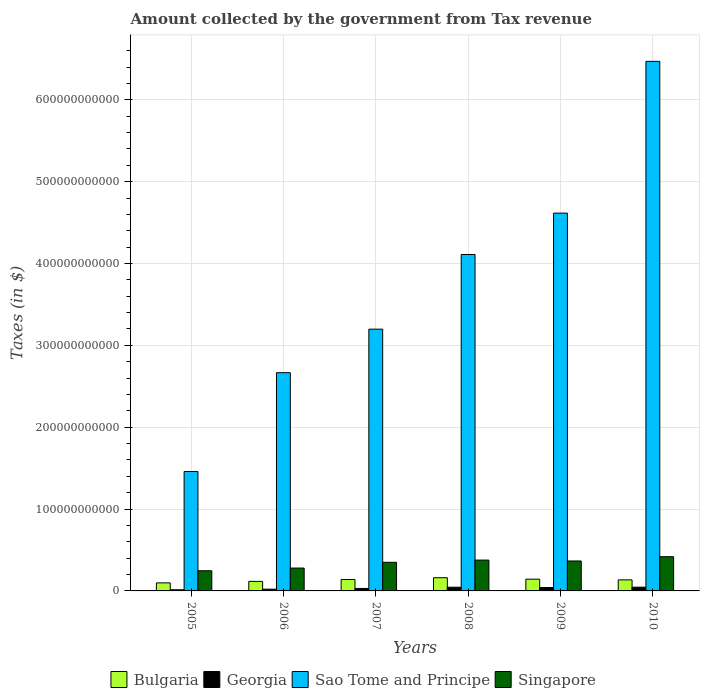How many groups of bars are there?
Your response must be concise. 6. Are the number of bars on each tick of the X-axis equal?
Ensure brevity in your answer.  Yes. How many bars are there on the 6th tick from the right?
Provide a short and direct response. 4. What is the label of the 6th group of bars from the left?
Give a very brief answer. 2010. What is the amount collected by the government from tax revenue in Sao Tome and Principe in 2009?
Your answer should be very brief. 4.62e+11. Across all years, what is the maximum amount collected by the government from tax revenue in Georgia?
Give a very brief answer. 4.59e+09. Across all years, what is the minimum amount collected by the government from tax revenue in Sao Tome and Principe?
Your response must be concise. 1.46e+11. In which year was the amount collected by the government from tax revenue in Bulgaria maximum?
Offer a terse response. 2008. In which year was the amount collected by the government from tax revenue in Singapore minimum?
Provide a short and direct response. 2005. What is the total amount collected by the government from tax revenue in Georgia in the graph?
Offer a very short reply. 1.98e+1. What is the difference between the amount collected by the government from tax revenue in Georgia in 2005 and that in 2009?
Make the answer very short. -2.75e+09. What is the difference between the amount collected by the government from tax revenue in Georgia in 2007 and the amount collected by the government from tax revenue in Singapore in 2010?
Make the answer very short. -3.88e+1. What is the average amount collected by the government from tax revenue in Singapore per year?
Your answer should be very brief. 3.39e+1. In the year 2008, what is the difference between the amount collected by the government from tax revenue in Georgia and amount collected by the government from tax revenue in Bulgaria?
Your response must be concise. -1.16e+1. In how many years, is the amount collected by the government from tax revenue in Sao Tome and Principe greater than 40000000000 $?
Give a very brief answer. 6. What is the ratio of the amount collected by the government from tax revenue in Sao Tome and Principe in 2005 to that in 2007?
Your answer should be very brief. 0.46. Is the amount collected by the government from tax revenue in Sao Tome and Principe in 2007 less than that in 2008?
Offer a terse response. Yes. Is the difference between the amount collected by the government from tax revenue in Georgia in 2008 and 2009 greater than the difference between the amount collected by the government from tax revenue in Bulgaria in 2008 and 2009?
Your answer should be very brief. No. What is the difference between the highest and the second highest amount collected by the government from tax revenue in Sao Tome and Principe?
Your answer should be compact. 1.85e+11. What is the difference between the highest and the lowest amount collected by the government from tax revenue in Bulgaria?
Provide a short and direct response. 6.30e+09. What does the 3rd bar from the left in 2006 represents?
Provide a succinct answer. Sao Tome and Principe. What does the 2nd bar from the right in 2005 represents?
Offer a terse response. Sao Tome and Principe. How many bars are there?
Offer a very short reply. 24. Are all the bars in the graph horizontal?
Offer a terse response. No. How many years are there in the graph?
Provide a short and direct response. 6. What is the difference between two consecutive major ticks on the Y-axis?
Make the answer very short. 1.00e+11. Are the values on the major ticks of Y-axis written in scientific E-notation?
Ensure brevity in your answer.  No. Does the graph contain grids?
Give a very brief answer. Yes. How many legend labels are there?
Provide a short and direct response. 4. How are the legend labels stacked?
Ensure brevity in your answer.  Horizontal. What is the title of the graph?
Offer a terse response. Amount collected by the government from Tax revenue. Does "Hungary" appear as one of the legend labels in the graph?
Give a very brief answer. No. What is the label or title of the X-axis?
Offer a very short reply. Years. What is the label or title of the Y-axis?
Your answer should be compact. Taxes (in $). What is the Taxes (in $) of Bulgaria in 2005?
Keep it short and to the point. 9.83e+09. What is the Taxes (in $) of Georgia in 2005?
Make the answer very short. 1.41e+09. What is the Taxes (in $) of Sao Tome and Principe in 2005?
Make the answer very short. 1.46e+11. What is the Taxes (in $) in Singapore in 2005?
Ensure brevity in your answer.  2.46e+1. What is the Taxes (in $) in Bulgaria in 2006?
Make the answer very short. 1.17e+1. What is the Taxes (in $) in Georgia in 2006?
Keep it short and to the point. 2.13e+09. What is the Taxes (in $) in Sao Tome and Principe in 2006?
Your answer should be compact. 2.67e+11. What is the Taxes (in $) of Singapore in 2006?
Offer a very short reply. 2.79e+1. What is the Taxes (in $) in Bulgaria in 2007?
Your response must be concise. 1.39e+1. What is the Taxes (in $) in Georgia in 2007?
Make the answer very short. 3.01e+09. What is the Taxes (in $) in Sao Tome and Principe in 2007?
Ensure brevity in your answer.  3.20e+11. What is the Taxes (in $) of Singapore in 2007?
Offer a very short reply. 3.50e+1. What is the Taxes (in $) of Bulgaria in 2008?
Make the answer very short. 1.61e+1. What is the Taxes (in $) of Georgia in 2008?
Give a very brief answer. 4.54e+09. What is the Taxes (in $) of Sao Tome and Principe in 2008?
Your answer should be compact. 4.11e+11. What is the Taxes (in $) in Singapore in 2008?
Provide a short and direct response. 3.77e+1. What is the Taxes (in $) of Bulgaria in 2009?
Provide a succinct answer. 1.44e+1. What is the Taxes (in $) in Georgia in 2009?
Make the answer very short. 4.16e+09. What is the Taxes (in $) of Sao Tome and Principe in 2009?
Your answer should be compact. 4.62e+11. What is the Taxes (in $) in Singapore in 2009?
Make the answer very short. 3.66e+1. What is the Taxes (in $) in Bulgaria in 2010?
Ensure brevity in your answer.  1.35e+1. What is the Taxes (in $) of Georgia in 2010?
Offer a terse response. 4.59e+09. What is the Taxes (in $) in Sao Tome and Principe in 2010?
Keep it short and to the point. 6.47e+11. What is the Taxes (in $) in Singapore in 2010?
Offer a terse response. 4.18e+1. Across all years, what is the maximum Taxes (in $) in Bulgaria?
Give a very brief answer. 1.61e+1. Across all years, what is the maximum Taxes (in $) of Georgia?
Provide a short and direct response. 4.59e+09. Across all years, what is the maximum Taxes (in $) in Sao Tome and Principe?
Your answer should be compact. 6.47e+11. Across all years, what is the maximum Taxes (in $) in Singapore?
Your answer should be very brief. 4.18e+1. Across all years, what is the minimum Taxes (in $) in Bulgaria?
Your answer should be very brief. 9.83e+09. Across all years, what is the minimum Taxes (in $) in Georgia?
Offer a very short reply. 1.41e+09. Across all years, what is the minimum Taxes (in $) of Sao Tome and Principe?
Offer a very short reply. 1.46e+11. Across all years, what is the minimum Taxes (in $) of Singapore?
Keep it short and to the point. 2.46e+1. What is the total Taxes (in $) in Bulgaria in the graph?
Your answer should be very brief. 7.94e+1. What is the total Taxes (in $) in Georgia in the graph?
Keep it short and to the point. 1.98e+1. What is the total Taxes (in $) of Sao Tome and Principe in the graph?
Your answer should be very brief. 2.25e+12. What is the total Taxes (in $) in Singapore in the graph?
Your response must be concise. 2.04e+11. What is the difference between the Taxes (in $) in Bulgaria in 2005 and that in 2006?
Give a very brief answer. -1.82e+09. What is the difference between the Taxes (in $) of Georgia in 2005 and that in 2006?
Provide a succinct answer. -7.23e+08. What is the difference between the Taxes (in $) in Sao Tome and Principe in 2005 and that in 2006?
Your response must be concise. -1.21e+11. What is the difference between the Taxes (in $) in Singapore in 2005 and that in 2006?
Your answer should be very brief. -3.31e+09. What is the difference between the Taxes (in $) of Bulgaria in 2005 and that in 2007?
Offer a very short reply. -4.09e+09. What is the difference between the Taxes (in $) of Georgia in 2005 and that in 2007?
Provide a short and direct response. -1.60e+09. What is the difference between the Taxes (in $) of Sao Tome and Principe in 2005 and that in 2007?
Your response must be concise. -1.74e+11. What is the difference between the Taxes (in $) of Singapore in 2005 and that in 2007?
Provide a short and direct response. -1.03e+1. What is the difference between the Taxes (in $) in Bulgaria in 2005 and that in 2008?
Give a very brief answer. -6.30e+09. What is the difference between the Taxes (in $) of Georgia in 2005 and that in 2008?
Offer a very short reply. -3.13e+09. What is the difference between the Taxes (in $) in Sao Tome and Principe in 2005 and that in 2008?
Offer a terse response. -2.65e+11. What is the difference between the Taxes (in $) in Singapore in 2005 and that in 2008?
Offer a terse response. -1.31e+1. What is the difference between the Taxes (in $) of Bulgaria in 2005 and that in 2009?
Your response must be concise. -4.53e+09. What is the difference between the Taxes (in $) of Georgia in 2005 and that in 2009?
Provide a short and direct response. -2.75e+09. What is the difference between the Taxes (in $) in Sao Tome and Principe in 2005 and that in 2009?
Your response must be concise. -3.16e+11. What is the difference between the Taxes (in $) of Singapore in 2005 and that in 2009?
Offer a terse response. -1.20e+1. What is the difference between the Taxes (in $) of Bulgaria in 2005 and that in 2010?
Give a very brief answer. -3.67e+09. What is the difference between the Taxes (in $) of Georgia in 2005 and that in 2010?
Provide a short and direct response. -3.19e+09. What is the difference between the Taxes (in $) of Sao Tome and Principe in 2005 and that in 2010?
Offer a very short reply. -5.01e+11. What is the difference between the Taxes (in $) in Singapore in 2005 and that in 2010?
Provide a short and direct response. -1.72e+1. What is the difference between the Taxes (in $) in Bulgaria in 2006 and that in 2007?
Keep it short and to the point. -2.27e+09. What is the difference between the Taxes (in $) of Georgia in 2006 and that in 2007?
Ensure brevity in your answer.  -8.80e+08. What is the difference between the Taxes (in $) of Sao Tome and Principe in 2006 and that in 2007?
Offer a very short reply. -5.32e+1. What is the difference between the Taxes (in $) of Singapore in 2006 and that in 2007?
Offer a terse response. -7.02e+09. What is the difference between the Taxes (in $) in Bulgaria in 2006 and that in 2008?
Provide a short and direct response. -4.47e+09. What is the difference between the Taxes (in $) of Georgia in 2006 and that in 2008?
Make the answer very short. -2.41e+09. What is the difference between the Taxes (in $) of Sao Tome and Principe in 2006 and that in 2008?
Your answer should be very brief. -1.44e+11. What is the difference between the Taxes (in $) of Singapore in 2006 and that in 2008?
Provide a succinct answer. -9.74e+09. What is the difference between the Taxes (in $) of Bulgaria in 2006 and that in 2009?
Keep it short and to the point. -2.71e+09. What is the difference between the Taxes (in $) of Georgia in 2006 and that in 2009?
Give a very brief answer. -2.03e+09. What is the difference between the Taxes (in $) in Sao Tome and Principe in 2006 and that in 2009?
Keep it short and to the point. -1.95e+11. What is the difference between the Taxes (in $) in Singapore in 2006 and that in 2009?
Provide a succinct answer. -8.64e+09. What is the difference between the Taxes (in $) in Bulgaria in 2006 and that in 2010?
Your response must be concise. -1.85e+09. What is the difference between the Taxes (in $) of Georgia in 2006 and that in 2010?
Your answer should be compact. -2.46e+09. What is the difference between the Taxes (in $) in Sao Tome and Principe in 2006 and that in 2010?
Your response must be concise. -3.80e+11. What is the difference between the Taxes (in $) in Singapore in 2006 and that in 2010?
Offer a very short reply. -1.39e+1. What is the difference between the Taxes (in $) in Bulgaria in 2007 and that in 2008?
Ensure brevity in your answer.  -2.20e+09. What is the difference between the Taxes (in $) of Georgia in 2007 and that in 2008?
Your response must be concise. -1.53e+09. What is the difference between the Taxes (in $) in Sao Tome and Principe in 2007 and that in 2008?
Keep it short and to the point. -9.12e+1. What is the difference between the Taxes (in $) of Singapore in 2007 and that in 2008?
Keep it short and to the point. -2.72e+09. What is the difference between the Taxes (in $) of Bulgaria in 2007 and that in 2009?
Offer a very short reply. -4.37e+08. What is the difference between the Taxes (in $) of Georgia in 2007 and that in 2009?
Your answer should be compact. -1.15e+09. What is the difference between the Taxes (in $) in Sao Tome and Principe in 2007 and that in 2009?
Provide a succinct answer. -1.42e+11. What is the difference between the Taxes (in $) of Singapore in 2007 and that in 2009?
Your response must be concise. -1.62e+09. What is the difference between the Taxes (in $) in Bulgaria in 2007 and that in 2010?
Your answer should be compact. 4.21e+08. What is the difference between the Taxes (in $) in Georgia in 2007 and that in 2010?
Provide a short and direct response. -1.58e+09. What is the difference between the Taxes (in $) in Sao Tome and Principe in 2007 and that in 2010?
Your answer should be compact. -3.27e+11. What is the difference between the Taxes (in $) in Singapore in 2007 and that in 2010?
Give a very brief answer. -6.85e+09. What is the difference between the Taxes (in $) in Bulgaria in 2008 and that in 2009?
Your response must be concise. 1.77e+09. What is the difference between the Taxes (in $) in Georgia in 2008 and that in 2009?
Your answer should be compact. 3.80e+08. What is the difference between the Taxes (in $) of Sao Tome and Principe in 2008 and that in 2009?
Your answer should be very brief. -5.06e+1. What is the difference between the Taxes (in $) of Singapore in 2008 and that in 2009?
Your answer should be very brief. 1.10e+09. What is the difference between the Taxes (in $) of Bulgaria in 2008 and that in 2010?
Make the answer very short. 2.62e+09. What is the difference between the Taxes (in $) in Georgia in 2008 and that in 2010?
Provide a short and direct response. -5.08e+07. What is the difference between the Taxes (in $) in Sao Tome and Principe in 2008 and that in 2010?
Make the answer very short. -2.36e+11. What is the difference between the Taxes (in $) in Singapore in 2008 and that in 2010?
Keep it short and to the point. -4.13e+09. What is the difference between the Taxes (in $) in Bulgaria in 2009 and that in 2010?
Make the answer very short. 8.58e+08. What is the difference between the Taxes (in $) in Georgia in 2009 and that in 2010?
Your answer should be compact. -4.31e+08. What is the difference between the Taxes (in $) of Sao Tome and Principe in 2009 and that in 2010?
Offer a very short reply. -1.85e+11. What is the difference between the Taxes (in $) of Singapore in 2009 and that in 2010?
Provide a succinct answer. -5.22e+09. What is the difference between the Taxes (in $) in Bulgaria in 2005 and the Taxes (in $) in Georgia in 2006?
Your answer should be very brief. 7.70e+09. What is the difference between the Taxes (in $) in Bulgaria in 2005 and the Taxes (in $) in Sao Tome and Principe in 2006?
Offer a terse response. -2.57e+11. What is the difference between the Taxes (in $) of Bulgaria in 2005 and the Taxes (in $) of Singapore in 2006?
Offer a very short reply. -1.81e+1. What is the difference between the Taxes (in $) in Georgia in 2005 and the Taxes (in $) in Sao Tome and Principe in 2006?
Offer a very short reply. -2.65e+11. What is the difference between the Taxes (in $) of Georgia in 2005 and the Taxes (in $) of Singapore in 2006?
Give a very brief answer. -2.65e+1. What is the difference between the Taxes (in $) of Sao Tome and Principe in 2005 and the Taxes (in $) of Singapore in 2006?
Offer a very short reply. 1.18e+11. What is the difference between the Taxes (in $) of Bulgaria in 2005 and the Taxes (in $) of Georgia in 2007?
Offer a terse response. 6.82e+09. What is the difference between the Taxes (in $) of Bulgaria in 2005 and the Taxes (in $) of Sao Tome and Principe in 2007?
Keep it short and to the point. -3.10e+11. What is the difference between the Taxes (in $) in Bulgaria in 2005 and the Taxes (in $) in Singapore in 2007?
Offer a terse response. -2.51e+1. What is the difference between the Taxes (in $) of Georgia in 2005 and the Taxes (in $) of Sao Tome and Principe in 2007?
Offer a terse response. -3.18e+11. What is the difference between the Taxes (in $) of Georgia in 2005 and the Taxes (in $) of Singapore in 2007?
Offer a very short reply. -3.36e+1. What is the difference between the Taxes (in $) of Sao Tome and Principe in 2005 and the Taxes (in $) of Singapore in 2007?
Keep it short and to the point. 1.11e+11. What is the difference between the Taxes (in $) of Bulgaria in 2005 and the Taxes (in $) of Georgia in 2008?
Your response must be concise. 5.29e+09. What is the difference between the Taxes (in $) of Bulgaria in 2005 and the Taxes (in $) of Sao Tome and Principe in 2008?
Make the answer very short. -4.01e+11. What is the difference between the Taxes (in $) of Bulgaria in 2005 and the Taxes (in $) of Singapore in 2008?
Offer a terse response. -2.78e+1. What is the difference between the Taxes (in $) of Georgia in 2005 and the Taxes (in $) of Sao Tome and Principe in 2008?
Keep it short and to the point. -4.10e+11. What is the difference between the Taxes (in $) of Georgia in 2005 and the Taxes (in $) of Singapore in 2008?
Your answer should be very brief. -3.63e+1. What is the difference between the Taxes (in $) in Sao Tome and Principe in 2005 and the Taxes (in $) in Singapore in 2008?
Offer a very short reply. 1.08e+11. What is the difference between the Taxes (in $) of Bulgaria in 2005 and the Taxes (in $) of Georgia in 2009?
Offer a very short reply. 5.67e+09. What is the difference between the Taxes (in $) of Bulgaria in 2005 and the Taxes (in $) of Sao Tome and Principe in 2009?
Make the answer very short. -4.52e+11. What is the difference between the Taxes (in $) in Bulgaria in 2005 and the Taxes (in $) in Singapore in 2009?
Ensure brevity in your answer.  -2.68e+1. What is the difference between the Taxes (in $) in Georgia in 2005 and the Taxes (in $) in Sao Tome and Principe in 2009?
Provide a short and direct response. -4.60e+11. What is the difference between the Taxes (in $) of Georgia in 2005 and the Taxes (in $) of Singapore in 2009?
Ensure brevity in your answer.  -3.52e+1. What is the difference between the Taxes (in $) of Sao Tome and Principe in 2005 and the Taxes (in $) of Singapore in 2009?
Offer a very short reply. 1.09e+11. What is the difference between the Taxes (in $) in Bulgaria in 2005 and the Taxes (in $) in Georgia in 2010?
Make the answer very short. 5.24e+09. What is the difference between the Taxes (in $) in Bulgaria in 2005 and the Taxes (in $) in Sao Tome and Principe in 2010?
Your answer should be compact. -6.37e+11. What is the difference between the Taxes (in $) of Bulgaria in 2005 and the Taxes (in $) of Singapore in 2010?
Ensure brevity in your answer.  -3.20e+1. What is the difference between the Taxes (in $) of Georgia in 2005 and the Taxes (in $) of Sao Tome and Principe in 2010?
Give a very brief answer. -6.46e+11. What is the difference between the Taxes (in $) of Georgia in 2005 and the Taxes (in $) of Singapore in 2010?
Your response must be concise. -4.04e+1. What is the difference between the Taxes (in $) of Sao Tome and Principe in 2005 and the Taxes (in $) of Singapore in 2010?
Your answer should be very brief. 1.04e+11. What is the difference between the Taxes (in $) in Bulgaria in 2006 and the Taxes (in $) in Georgia in 2007?
Offer a terse response. 8.64e+09. What is the difference between the Taxes (in $) in Bulgaria in 2006 and the Taxes (in $) in Sao Tome and Principe in 2007?
Give a very brief answer. -3.08e+11. What is the difference between the Taxes (in $) in Bulgaria in 2006 and the Taxes (in $) in Singapore in 2007?
Ensure brevity in your answer.  -2.33e+1. What is the difference between the Taxes (in $) of Georgia in 2006 and the Taxes (in $) of Sao Tome and Principe in 2007?
Your answer should be compact. -3.18e+11. What is the difference between the Taxes (in $) in Georgia in 2006 and the Taxes (in $) in Singapore in 2007?
Keep it short and to the point. -3.28e+1. What is the difference between the Taxes (in $) of Sao Tome and Principe in 2006 and the Taxes (in $) of Singapore in 2007?
Your answer should be very brief. 2.32e+11. What is the difference between the Taxes (in $) of Bulgaria in 2006 and the Taxes (in $) of Georgia in 2008?
Give a very brief answer. 7.11e+09. What is the difference between the Taxes (in $) of Bulgaria in 2006 and the Taxes (in $) of Sao Tome and Principe in 2008?
Provide a short and direct response. -3.99e+11. What is the difference between the Taxes (in $) of Bulgaria in 2006 and the Taxes (in $) of Singapore in 2008?
Make the answer very short. -2.60e+1. What is the difference between the Taxes (in $) in Georgia in 2006 and the Taxes (in $) in Sao Tome and Principe in 2008?
Your answer should be compact. -4.09e+11. What is the difference between the Taxes (in $) of Georgia in 2006 and the Taxes (in $) of Singapore in 2008?
Give a very brief answer. -3.55e+1. What is the difference between the Taxes (in $) in Sao Tome and Principe in 2006 and the Taxes (in $) in Singapore in 2008?
Provide a succinct answer. 2.29e+11. What is the difference between the Taxes (in $) of Bulgaria in 2006 and the Taxes (in $) of Georgia in 2009?
Ensure brevity in your answer.  7.49e+09. What is the difference between the Taxes (in $) in Bulgaria in 2006 and the Taxes (in $) in Sao Tome and Principe in 2009?
Keep it short and to the point. -4.50e+11. What is the difference between the Taxes (in $) in Bulgaria in 2006 and the Taxes (in $) in Singapore in 2009?
Ensure brevity in your answer.  -2.49e+1. What is the difference between the Taxes (in $) in Georgia in 2006 and the Taxes (in $) in Sao Tome and Principe in 2009?
Make the answer very short. -4.59e+11. What is the difference between the Taxes (in $) of Georgia in 2006 and the Taxes (in $) of Singapore in 2009?
Provide a succinct answer. -3.45e+1. What is the difference between the Taxes (in $) in Sao Tome and Principe in 2006 and the Taxes (in $) in Singapore in 2009?
Give a very brief answer. 2.30e+11. What is the difference between the Taxes (in $) in Bulgaria in 2006 and the Taxes (in $) in Georgia in 2010?
Ensure brevity in your answer.  7.06e+09. What is the difference between the Taxes (in $) in Bulgaria in 2006 and the Taxes (in $) in Sao Tome and Principe in 2010?
Provide a short and direct response. -6.35e+11. What is the difference between the Taxes (in $) of Bulgaria in 2006 and the Taxes (in $) of Singapore in 2010?
Ensure brevity in your answer.  -3.02e+1. What is the difference between the Taxes (in $) in Georgia in 2006 and the Taxes (in $) in Sao Tome and Principe in 2010?
Your answer should be very brief. -6.45e+11. What is the difference between the Taxes (in $) of Georgia in 2006 and the Taxes (in $) of Singapore in 2010?
Provide a succinct answer. -3.97e+1. What is the difference between the Taxes (in $) in Sao Tome and Principe in 2006 and the Taxes (in $) in Singapore in 2010?
Offer a very short reply. 2.25e+11. What is the difference between the Taxes (in $) in Bulgaria in 2007 and the Taxes (in $) in Georgia in 2008?
Provide a succinct answer. 9.38e+09. What is the difference between the Taxes (in $) of Bulgaria in 2007 and the Taxes (in $) of Sao Tome and Principe in 2008?
Make the answer very short. -3.97e+11. What is the difference between the Taxes (in $) in Bulgaria in 2007 and the Taxes (in $) in Singapore in 2008?
Your response must be concise. -2.38e+1. What is the difference between the Taxes (in $) of Georgia in 2007 and the Taxes (in $) of Sao Tome and Principe in 2008?
Give a very brief answer. -4.08e+11. What is the difference between the Taxes (in $) of Georgia in 2007 and the Taxes (in $) of Singapore in 2008?
Provide a succinct answer. -3.47e+1. What is the difference between the Taxes (in $) of Sao Tome and Principe in 2007 and the Taxes (in $) of Singapore in 2008?
Give a very brief answer. 2.82e+11. What is the difference between the Taxes (in $) in Bulgaria in 2007 and the Taxes (in $) in Georgia in 2009?
Provide a short and direct response. 9.76e+09. What is the difference between the Taxes (in $) in Bulgaria in 2007 and the Taxes (in $) in Sao Tome and Principe in 2009?
Ensure brevity in your answer.  -4.48e+11. What is the difference between the Taxes (in $) of Bulgaria in 2007 and the Taxes (in $) of Singapore in 2009?
Make the answer very short. -2.27e+1. What is the difference between the Taxes (in $) of Georgia in 2007 and the Taxes (in $) of Sao Tome and Principe in 2009?
Offer a very short reply. -4.59e+11. What is the difference between the Taxes (in $) in Georgia in 2007 and the Taxes (in $) in Singapore in 2009?
Your response must be concise. -3.36e+1. What is the difference between the Taxes (in $) of Sao Tome and Principe in 2007 and the Taxes (in $) of Singapore in 2009?
Keep it short and to the point. 2.83e+11. What is the difference between the Taxes (in $) in Bulgaria in 2007 and the Taxes (in $) in Georgia in 2010?
Your answer should be very brief. 9.33e+09. What is the difference between the Taxes (in $) in Bulgaria in 2007 and the Taxes (in $) in Sao Tome and Principe in 2010?
Your answer should be compact. -6.33e+11. What is the difference between the Taxes (in $) of Bulgaria in 2007 and the Taxes (in $) of Singapore in 2010?
Your answer should be very brief. -2.79e+1. What is the difference between the Taxes (in $) of Georgia in 2007 and the Taxes (in $) of Sao Tome and Principe in 2010?
Offer a very short reply. -6.44e+11. What is the difference between the Taxes (in $) of Georgia in 2007 and the Taxes (in $) of Singapore in 2010?
Offer a very short reply. -3.88e+1. What is the difference between the Taxes (in $) in Sao Tome and Principe in 2007 and the Taxes (in $) in Singapore in 2010?
Offer a terse response. 2.78e+11. What is the difference between the Taxes (in $) of Bulgaria in 2008 and the Taxes (in $) of Georgia in 2009?
Give a very brief answer. 1.20e+1. What is the difference between the Taxes (in $) of Bulgaria in 2008 and the Taxes (in $) of Sao Tome and Principe in 2009?
Keep it short and to the point. -4.45e+11. What is the difference between the Taxes (in $) of Bulgaria in 2008 and the Taxes (in $) of Singapore in 2009?
Provide a succinct answer. -2.05e+1. What is the difference between the Taxes (in $) in Georgia in 2008 and the Taxes (in $) in Sao Tome and Principe in 2009?
Provide a short and direct response. -4.57e+11. What is the difference between the Taxes (in $) of Georgia in 2008 and the Taxes (in $) of Singapore in 2009?
Provide a short and direct response. -3.20e+1. What is the difference between the Taxes (in $) in Sao Tome and Principe in 2008 and the Taxes (in $) in Singapore in 2009?
Offer a very short reply. 3.74e+11. What is the difference between the Taxes (in $) of Bulgaria in 2008 and the Taxes (in $) of Georgia in 2010?
Offer a terse response. 1.15e+1. What is the difference between the Taxes (in $) of Bulgaria in 2008 and the Taxes (in $) of Sao Tome and Principe in 2010?
Give a very brief answer. -6.31e+11. What is the difference between the Taxes (in $) in Bulgaria in 2008 and the Taxes (in $) in Singapore in 2010?
Your answer should be very brief. -2.57e+1. What is the difference between the Taxes (in $) in Georgia in 2008 and the Taxes (in $) in Sao Tome and Principe in 2010?
Offer a terse response. -6.42e+11. What is the difference between the Taxes (in $) in Georgia in 2008 and the Taxes (in $) in Singapore in 2010?
Keep it short and to the point. -3.73e+1. What is the difference between the Taxes (in $) in Sao Tome and Principe in 2008 and the Taxes (in $) in Singapore in 2010?
Give a very brief answer. 3.69e+11. What is the difference between the Taxes (in $) of Bulgaria in 2009 and the Taxes (in $) of Georgia in 2010?
Keep it short and to the point. 9.77e+09. What is the difference between the Taxes (in $) in Bulgaria in 2009 and the Taxes (in $) in Sao Tome and Principe in 2010?
Provide a succinct answer. -6.33e+11. What is the difference between the Taxes (in $) of Bulgaria in 2009 and the Taxes (in $) of Singapore in 2010?
Provide a succinct answer. -2.74e+1. What is the difference between the Taxes (in $) of Georgia in 2009 and the Taxes (in $) of Sao Tome and Principe in 2010?
Provide a succinct answer. -6.43e+11. What is the difference between the Taxes (in $) in Georgia in 2009 and the Taxes (in $) in Singapore in 2010?
Your response must be concise. -3.76e+1. What is the difference between the Taxes (in $) of Sao Tome and Principe in 2009 and the Taxes (in $) of Singapore in 2010?
Ensure brevity in your answer.  4.20e+11. What is the average Taxes (in $) of Bulgaria per year?
Make the answer very short. 1.32e+1. What is the average Taxes (in $) in Georgia per year?
Offer a very short reply. 3.31e+09. What is the average Taxes (in $) of Sao Tome and Principe per year?
Ensure brevity in your answer.  3.75e+11. What is the average Taxes (in $) in Singapore per year?
Your answer should be very brief. 3.39e+1. In the year 2005, what is the difference between the Taxes (in $) in Bulgaria and Taxes (in $) in Georgia?
Offer a terse response. 8.42e+09. In the year 2005, what is the difference between the Taxes (in $) of Bulgaria and Taxes (in $) of Sao Tome and Principe?
Offer a terse response. -1.36e+11. In the year 2005, what is the difference between the Taxes (in $) of Bulgaria and Taxes (in $) of Singapore?
Your response must be concise. -1.48e+1. In the year 2005, what is the difference between the Taxes (in $) of Georgia and Taxes (in $) of Sao Tome and Principe?
Give a very brief answer. -1.44e+11. In the year 2005, what is the difference between the Taxes (in $) of Georgia and Taxes (in $) of Singapore?
Provide a succinct answer. -2.32e+1. In the year 2005, what is the difference between the Taxes (in $) of Sao Tome and Principe and Taxes (in $) of Singapore?
Your answer should be very brief. 1.21e+11. In the year 2006, what is the difference between the Taxes (in $) in Bulgaria and Taxes (in $) in Georgia?
Ensure brevity in your answer.  9.52e+09. In the year 2006, what is the difference between the Taxes (in $) of Bulgaria and Taxes (in $) of Sao Tome and Principe?
Your response must be concise. -2.55e+11. In the year 2006, what is the difference between the Taxes (in $) of Bulgaria and Taxes (in $) of Singapore?
Offer a terse response. -1.63e+1. In the year 2006, what is the difference between the Taxes (in $) in Georgia and Taxes (in $) in Sao Tome and Principe?
Make the answer very short. -2.64e+11. In the year 2006, what is the difference between the Taxes (in $) in Georgia and Taxes (in $) in Singapore?
Your answer should be compact. -2.58e+1. In the year 2006, what is the difference between the Taxes (in $) in Sao Tome and Principe and Taxes (in $) in Singapore?
Ensure brevity in your answer.  2.39e+11. In the year 2007, what is the difference between the Taxes (in $) of Bulgaria and Taxes (in $) of Georgia?
Provide a short and direct response. 1.09e+1. In the year 2007, what is the difference between the Taxes (in $) in Bulgaria and Taxes (in $) in Sao Tome and Principe?
Your response must be concise. -3.06e+11. In the year 2007, what is the difference between the Taxes (in $) in Bulgaria and Taxes (in $) in Singapore?
Make the answer very short. -2.10e+1. In the year 2007, what is the difference between the Taxes (in $) in Georgia and Taxes (in $) in Sao Tome and Principe?
Your answer should be very brief. -3.17e+11. In the year 2007, what is the difference between the Taxes (in $) of Georgia and Taxes (in $) of Singapore?
Your answer should be compact. -3.20e+1. In the year 2007, what is the difference between the Taxes (in $) of Sao Tome and Principe and Taxes (in $) of Singapore?
Give a very brief answer. 2.85e+11. In the year 2008, what is the difference between the Taxes (in $) of Bulgaria and Taxes (in $) of Georgia?
Make the answer very short. 1.16e+1. In the year 2008, what is the difference between the Taxes (in $) of Bulgaria and Taxes (in $) of Sao Tome and Principe?
Ensure brevity in your answer.  -3.95e+11. In the year 2008, what is the difference between the Taxes (in $) of Bulgaria and Taxes (in $) of Singapore?
Ensure brevity in your answer.  -2.16e+1. In the year 2008, what is the difference between the Taxes (in $) in Georgia and Taxes (in $) in Sao Tome and Principe?
Provide a short and direct response. -4.06e+11. In the year 2008, what is the difference between the Taxes (in $) in Georgia and Taxes (in $) in Singapore?
Offer a very short reply. -3.31e+1. In the year 2008, what is the difference between the Taxes (in $) of Sao Tome and Principe and Taxes (in $) of Singapore?
Your response must be concise. 3.73e+11. In the year 2009, what is the difference between the Taxes (in $) in Bulgaria and Taxes (in $) in Georgia?
Ensure brevity in your answer.  1.02e+1. In the year 2009, what is the difference between the Taxes (in $) of Bulgaria and Taxes (in $) of Sao Tome and Principe?
Offer a terse response. -4.47e+11. In the year 2009, what is the difference between the Taxes (in $) in Bulgaria and Taxes (in $) in Singapore?
Offer a terse response. -2.22e+1. In the year 2009, what is the difference between the Taxes (in $) of Georgia and Taxes (in $) of Sao Tome and Principe?
Provide a succinct answer. -4.57e+11. In the year 2009, what is the difference between the Taxes (in $) in Georgia and Taxes (in $) in Singapore?
Make the answer very short. -3.24e+1. In the year 2009, what is the difference between the Taxes (in $) of Sao Tome and Principe and Taxes (in $) of Singapore?
Your response must be concise. 4.25e+11. In the year 2010, what is the difference between the Taxes (in $) of Bulgaria and Taxes (in $) of Georgia?
Your answer should be very brief. 8.91e+09. In the year 2010, what is the difference between the Taxes (in $) of Bulgaria and Taxes (in $) of Sao Tome and Principe?
Offer a terse response. -6.33e+11. In the year 2010, what is the difference between the Taxes (in $) of Bulgaria and Taxes (in $) of Singapore?
Your response must be concise. -2.83e+1. In the year 2010, what is the difference between the Taxes (in $) of Georgia and Taxes (in $) of Sao Tome and Principe?
Your answer should be very brief. -6.42e+11. In the year 2010, what is the difference between the Taxes (in $) in Georgia and Taxes (in $) in Singapore?
Offer a terse response. -3.72e+1. In the year 2010, what is the difference between the Taxes (in $) of Sao Tome and Principe and Taxes (in $) of Singapore?
Offer a terse response. 6.05e+11. What is the ratio of the Taxes (in $) in Bulgaria in 2005 to that in 2006?
Offer a terse response. 0.84. What is the ratio of the Taxes (in $) of Georgia in 2005 to that in 2006?
Give a very brief answer. 0.66. What is the ratio of the Taxes (in $) in Sao Tome and Principe in 2005 to that in 2006?
Your response must be concise. 0.55. What is the ratio of the Taxes (in $) in Singapore in 2005 to that in 2006?
Offer a terse response. 0.88. What is the ratio of the Taxes (in $) of Bulgaria in 2005 to that in 2007?
Provide a succinct answer. 0.71. What is the ratio of the Taxes (in $) in Georgia in 2005 to that in 2007?
Offer a terse response. 0.47. What is the ratio of the Taxes (in $) in Sao Tome and Principe in 2005 to that in 2007?
Keep it short and to the point. 0.46. What is the ratio of the Taxes (in $) of Singapore in 2005 to that in 2007?
Offer a very short reply. 0.7. What is the ratio of the Taxes (in $) of Bulgaria in 2005 to that in 2008?
Your answer should be compact. 0.61. What is the ratio of the Taxes (in $) of Georgia in 2005 to that in 2008?
Your answer should be very brief. 0.31. What is the ratio of the Taxes (in $) of Sao Tome and Principe in 2005 to that in 2008?
Your answer should be compact. 0.35. What is the ratio of the Taxes (in $) in Singapore in 2005 to that in 2008?
Ensure brevity in your answer.  0.65. What is the ratio of the Taxes (in $) of Bulgaria in 2005 to that in 2009?
Provide a succinct answer. 0.68. What is the ratio of the Taxes (in $) of Georgia in 2005 to that in 2009?
Offer a terse response. 0.34. What is the ratio of the Taxes (in $) of Sao Tome and Principe in 2005 to that in 2009?
Provide a short and direct response. 0.32. What is the ratio of the Taxes (in $) of Singapore in 2005 to that in 2009?
Ensure brevity in your answer.  0.67. What is the ratio of the Taxes (in $) of Bulgaria in 2005 to that in 2010?
Provide a short and direct response. 0.73. What is the ratio of the Taxes (in $) in Georgia in 2005 to that in 2010?
Offer a terse response. 0.31. What is the ratio of the Taxes (in $) of Sao Tome and Principe in 2005 to that in 2010?
Your answer should be very brief. 0.23. What is the ratio of the Taxes (in $) in Singapore in 2005 to that in 2010?
Give a very brief answer. 0.59. What is the ratio of the Taxes (in $) of Bulgaria in 2006 to that in 2007?
Make the answer very short. 0.84. What is the ratio of the Taxes (in $) in Georgia in 2006 to that in 2007?
Provide a short and direct response. 0.71. What is the ratio of the Taxes (in $) of Sao Tome and Principe in 2006 to that in 2007?
Your response must be concise. 0.83. What is the ratio of the Taxes (in $) of Singapore in 2006 to that in 2007?
Ensure brevity in your answer.  0.8. What is the ratio of the Taxes (in $) in Bulgaria in 2006 to that in 2008?
Your response must be concise. 0.72. What is the ratio of the Taxes (in $) of Georgia in 2006 to that in 2008?
Your response must be concise. 0.47. What is the ratio of the Taxes (in $) of Sao Tome and Principe in 2006 to that in 2008?
Offer a terse response. 0.65. What is the ratio of the Taxes (in $) in Singapore in 2006 to that in 2008?
Provide a short and direct response. 0.74. What is the ratio of the Taxes (in $) of Bulgaria in 2006 to that in 2009?
Offer a very short reply. 0.81. What is the ratio of the Taxes (in $) in Georgia in 2006 to that in 2009?
Give a very brief answer. 0.51. What is the ratio of the Taxes (in $) of Sao Tome and Principe in 2006 to that in 2009?
Provide a succinct answer. 0.58. What is the ratio of the Taxes (in $) in Singapore in 2006 to that in 2009?
Make the answer very short. 0.76. What is the ratio of the Taxes (in $) in Bulgaria in 2006 to that in 2010?
Your answer should be compact. 0.86. What is the ratio of the Taxes (in $) of Georgia in 2006 to that in 2010?
Provide a short and direct response. 0.46. What is the ratio of the Taxes (in $) in Sao Tome and Principe in 2006 to that in 2010?
Your answer should be compact. 0.41. What is the ratio of the Taxes (in $) in Singapore in 2006 to that in 2010?
Keep it short and to the point. 0.67. What is the ratio of the Taxes (in $) of Bulgaria in 2007 to that in 2008?
Ensure brevity in your answer.  0.86. What is the ratio of the Taxes (in $) of Georgia in 2007 to that in 2008?
Offer a very short reply. 0.66. What is the ratio of the Taxes (in $) of Sao Tome and Principe in 2007 to that in 2008?
Your answer should be compact. 0.78. What is the ratio of the Taxes (in $) in Singapore in 2007 to that in 2008?
Your answer should be compact. 0.93. What is the ratio of the Taxes (in $) of Bulgaria in 2007 to that in 2009?
Keep it short and to the point. 0.97. What is the ratio of the Taxes (in $) of Georgia in 2007 to that in 2009?
Make the answer very short. 0.72. What is the ratio of the Taxes (in $) in Sao Tome and Principe in 2007 to that in 2009?
Ensure brevity in your answer.  0.69. What is the ratio of the Taxes (in $) of Singapore in 2007 to that in 2009?
Your answer should be very brief. 0.96. What is the ratio of the Taxes (in $) of Bulgaria in 2007 to that in 2010?
Your answer should be very brief. 1.03. What is the ratio of the Taxes (in $) of Georgia in 2007 to that in 2010?
Provide a short and direct response. 0.66. What is the ratio of the Taxes (in $) of Sao Tome and Principe in 2007 to that in 2010?
Give a very brief answer. 0.49. What is the ratio of the Taxes (in $) of Singapore in 2007 to that in 2010?
Your answer should be compact. 0.84. What is the ratio of the Taxes (in $) of Bulgaria in 2008 to that in 2009?
Ensure brevity in your answer.  1.12. What is the ratio of the Taxes (in $) in Georgia in 2008 to that in 2009?
Provide a short and direct response. 1.09. What is the ratio of the Taxes (in $) of Sao Tome and Principe in 2008 to that in 2009?
Give a very brief answer. 0.89. What is the ratio of the Taxes (in $) in Singapore in 2008 to that in 2009?
Offer a terse response. 1.03. What is the ratio of the Taxes (in $) of Bulgaria in 2008 to that in 2010?
Your answer should be compact. 1.19. What is the ratio of the Taxes (in $) of Georgia in 2008 to that in 2010?
Offer a very short reply. 0.99. What is the ratio of the Taxes (in $) in Sao Tome and Principe in 2008 to that in 2010?
Your answer should be compact. 0.64. What is the ratio of the Taxes (in $) of Singapore in 2008 to that in 2010?
Ensure brevity in your answer.  0.9. What is the ratio of the Taxes (in $) of Bulgaria in 2009 to that in 2010?
Ensure brevity in your answer.  1.06. What is the ratio of the Taxes (in $) in Georgia in 2009 to that in 2010?
Provide a succinct answer. 0.91. What is the ratio of the Taxes (in $) of Sao Tome and Principe in 2009 to that in 2010?
Provide a succinct answer. 0.71. What is the ratio of the Taxes (in $) of Singapore in 2009 to that in 2010?
Your answer should be very brief. 0.88. What is the difference between the highest and the second highest Taxes (in $) in Bulgaria?
Give a very brief answer. 1.77e+09. What is the difference between the highest and the second highest Taxes (in $) in Georgia?
Ensure brevity in your answer.  5.08e+07. What is the difference between the highest and the second highest Taxes (in $) in Sao Tome and Principe?
Your response must be concise. 1.85e+11. What is the difference between the highest and the second highest Taxes (in $) in Singapore?
Make the answer very short. 4.13e+09. What is the difference between the highest and the lowest Taxes (in $) in Bulgaria?
Offer a terse response. 6.30e+09. What is the difference between the highest and the lowest Taxes (in $) in Georgia?
Make the answer very short. 3.19e+09. What is the difference between the highest and the lowest Taxes (in $) of Sao Tome and Principe?
Offer a very short reply. 5.01e+11. What is the difference between the highest and the lowest Taxes (in $) of Singapore?
Your response must be concise. 1.72e+1. 